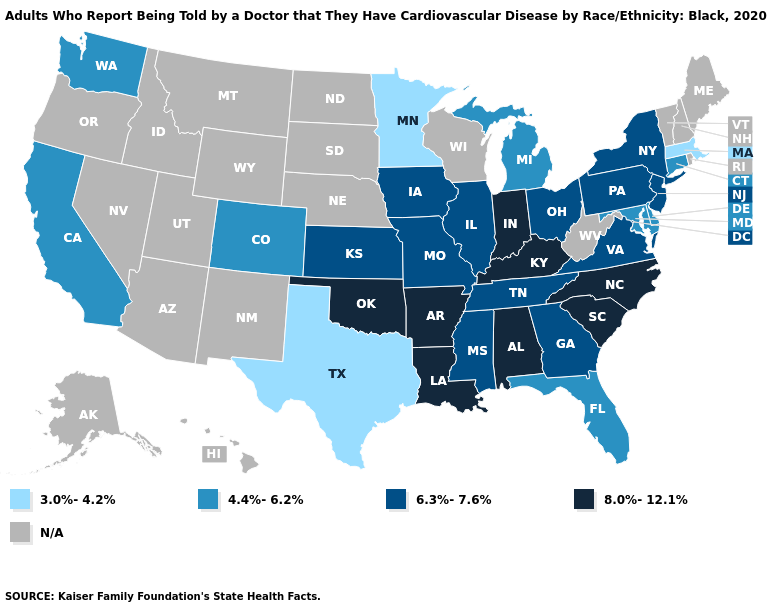What is the value of Arizona?
Give a very brief answer. N/A. Among the states that border Wisconsin , does Minnesota have the highest value?
Write a very short answer. No. What is the highest value in the South ?
Answer briefly. 8.0%-12.1%. What is the value of Georgia?
Give a very brief answer. 6.3%-7.6%. Which states have the highest value in the USA?
Write a very short answer. Alabama, Arkansas, Indiana, Kentucky, Louisiana, North Carolina, Oklahoma, South Carolina. What is the value of Kentucky?
Keep it brief. 8.0%-12.1%. What is the value of Florida?
Keep it brief. 4.4%-6.2%. Is the legend a continuous bar?
Short answer required. No. Does the first symbol in the legend represent the smallest category?
Write a very short answer. Yes. Does Missouri have the lowest value in the USA?
Answer briefly. No. What is the highest value in the Northeast ?
Write a very short answer. 6.3%-7.6%. What is the value of Hawaii?
Quick response, please. N/A. Does the first symbol in the legend represent the smallest category?
Write a very short answer. Yes. Name the states that have a value in the range 6.3%-7.6%?
Answer briefly. Georgia, Illinois, Iowa, Kansas, Mississippi, Missouri, New Jersey, New York, Ohio, Pennsylvania, Tennessee, Virginia. Does the map have missing data?
Give a very brief answer. Yes. 